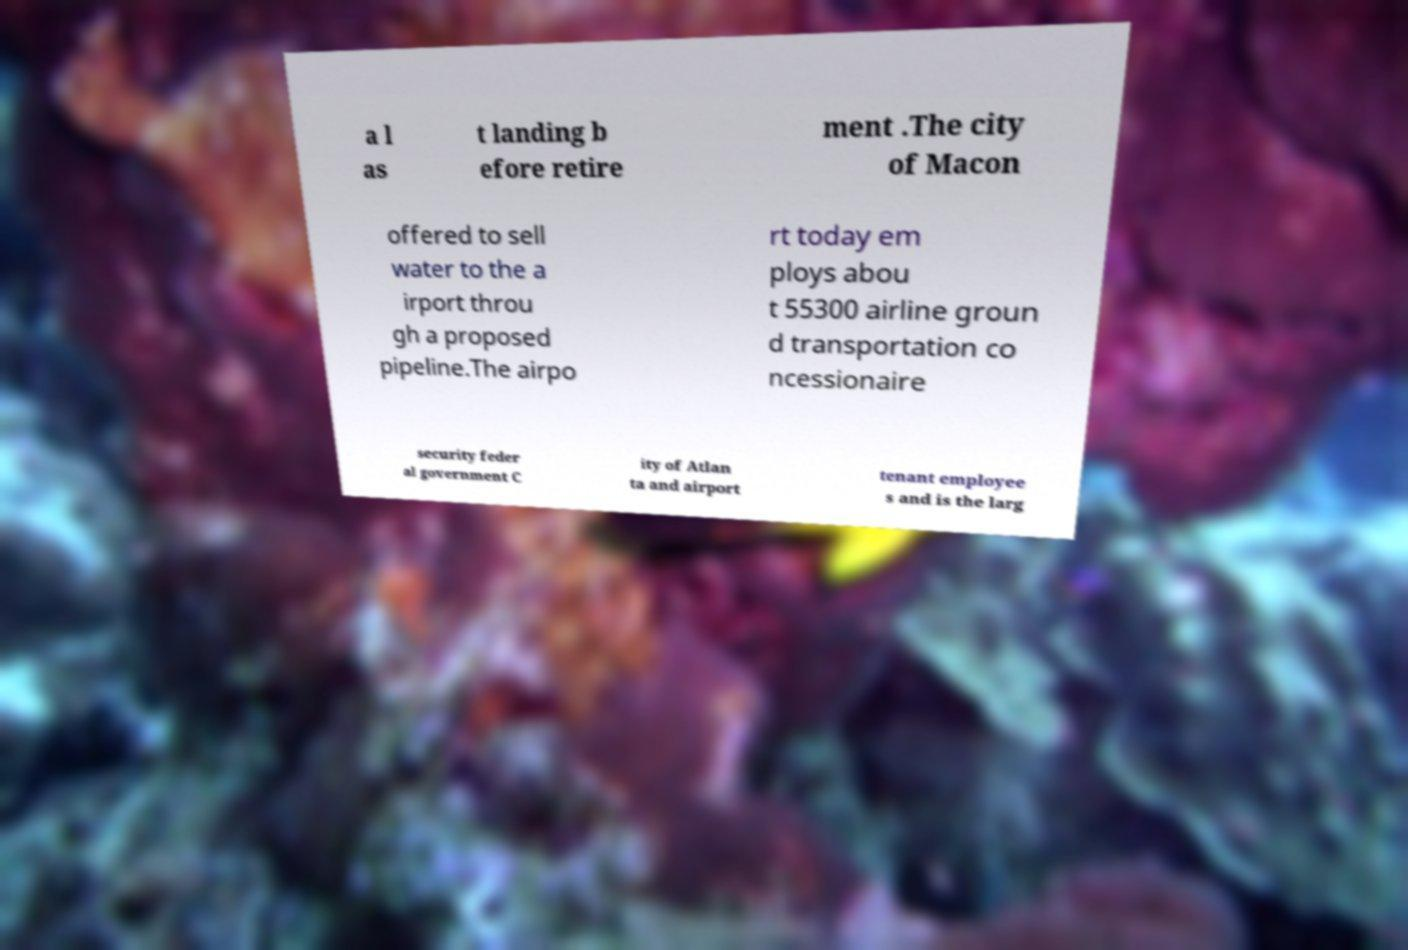Can you read and provide the text displayed in the image?This photo seems to have some interesting text. Can you extract and type it out for me? a l as t landing b efore retire ment .The city of Macon offered to sell water to the a irport throu gh a proposed pipeline.The airpo rt today em ploys abou t 55300 airline groun d transportation co ncessionaire security feder al government C ity of Atlan ta and airport tenant employee s and is the larg 